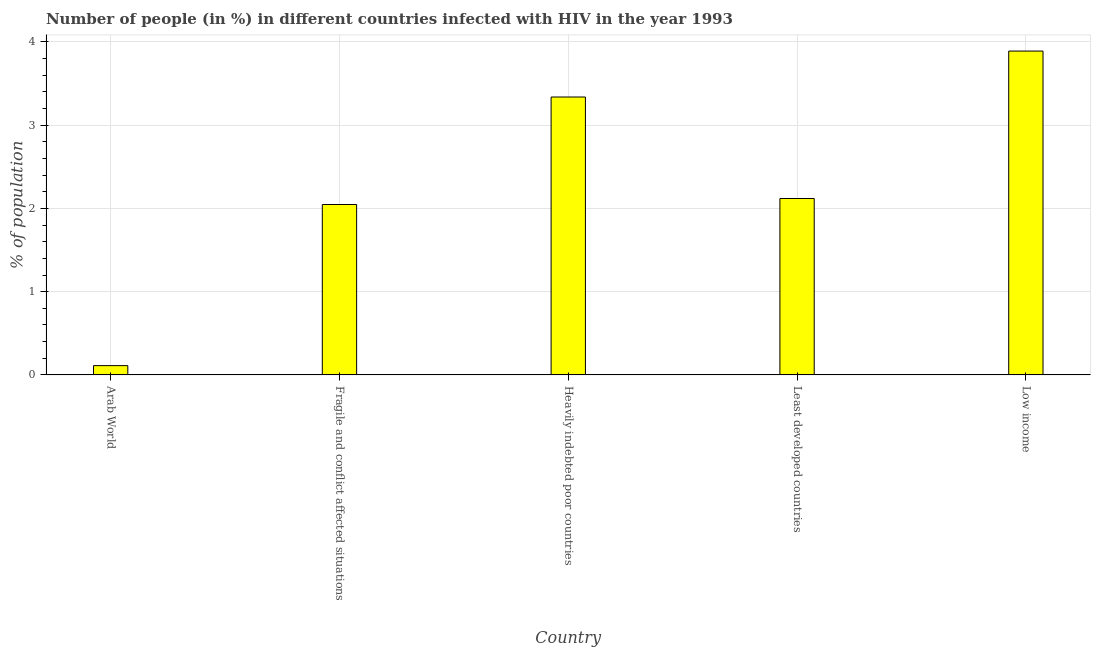Does the graph contain any zero values?
Provide a short and direct response. No. What is the title of the graph?
Provide a short and direct response. Number of people (in %) in different countries infected with HIV in the year 1993. What is the label or title of the Y-axis?
Give a very brief answer. % of population. What is the number of people infected with hiv in Arab World?
Provide a short and direct response. 0.11. Across all countries, what is the maximum number of people infected with hiv?
Your answer should be compact. 3.89. Across all countries, what is the minimum number of people infected with hiv?
Give a very brief answer. 0.11. In which country was the number of people infected with hiv maximum?
Offer a terse response. Low income. In which country was the number of people infected with hiv minimum?
Give a very brief answer. Arab World. What is the sum of the number of people infected with hiv?
Provide a short and direct response. 11.51. What is the difference between the number of people infected with hiv in Heavily indebted poor countries and Low income?
Give a very brief answer. -0.55. What is the average number of people infected with hiv per country?
Provide a short and direct response. 2.3. What is the median number of people infected with hiv?
Your answer should be compact. 2.12. What is the ratio of the number of people infected with hiv in Fragile and conflict affected situations to that in Heavily indebted poor countries?
Provide a short and direct response. 0.61. Is the number of people infected with hiv in Heavily indebted poor countries less than that in Least developed countries?
Your answer should be compact. No. Is the difference between the number of people infected with hiv in Arab World and Least developed countries greater than the difference between any two countries?
Offer a terse response. No. What is the difference between the highest and the second highest number of people infected with hiv?
Provide a succinct answer. 0.55. Is the sum of the number of people infected with hiv in Arab World and Low income greater than the maximum number of people infected with hiv across all countries?
Keep it short and to the point. Yes. What is the difference between the highest and the lowest number of people infected with hiv?
Provide a succinct answer. 3.78. In how many countries, is the number of people infected with hiv greater than the average number of people infected with hiv taken over all countries?
Provide a succinct answer. 2. What is the % of population of Arab World?
Your answer should be very brief. 0.11. What is the % of population in Fragile and conflict affected situations?
Your answer should be compact. 2.05. What is the % of population of Heavily indebted poor countries?
Offer a very short reply. 3.34. What is the % of population in Least developed countries?
Keep it short and to the point. 2.12. What is the % of population of Low income?
Make the answer very short. 3.89. What is the difference between the % of population in Arab World and Fragile and conflict affected situations?
Your answer should be very brief. -1.94. What is the difference between the % of population in Arab World and Heavily indebted poor countries?
Provide a succinct answer. -3.23. What is the difference between the % of population in Arab World and Least developed countries?
Your answer should be very brief. -2.01. What is the difference between the % of population in Arab World and Low income?
Provide a succinct answer. -3.78. What is the difference between the % of population in Fragile and conflict affected situations and Heavily indebted poor countries?
Your response must be concise. -1.29. What is the difference between the % of population in Fragile and conflict affected situations and Least developed countries?
Provide a short and direct response. -0.07. What is the difference between the % of population in Fragile and conflict affected situations and Low income?
Your answer should be very brief. -1.84. What is the difference between the % of population in Heavily indebted poor countries and Least developed countries?
Keep it short and to the point. 1.22. What is the difference between the % of population in Heavily indebted poor countries and Low income?
Offer a very short reply. -0.55. What is the difference between the % of population in Least developed countries and Low income?
Make the answer very short. -1.77. What is the ratio of the % of population in Arab World to that in Fragile and conflict affected situations?
Offer a terse response. 0.05. What is the ratio of the % of population in Arab World to that in Heavily indebted poor countries?
Ensure brevity in your answer.  0.03. What is the ratio of the % of population in Arab World to that in Least developed countries?
Offer a very short reply. 0.05. What is the ratio of the % of population in Arab World to that in Low income?
Provide a succinct answer. 0.03. What is the ratio of the % of population in Fragile and conflict affected situations to that in Heavily indebted poor countries?
Ensure brevity in your answer.  0.61. What is the ratio of the % of population in Fragile and conflict affected situations to that in Least developed countries?
Your answer should be very brief. 0.97. What is the ratio of the % of population in Fragile and conflict affected situations to that in Low income?
Offer a terse response. 0.53. What is the ratio of the % of population in Heavily indebted poor countries to that in Least developed countries?
Ensure brevity in your answer.  1.57. What is the ratio of the % of population in Heavily indebted poor countries to that in Low income?
Make the answer very short. 0.86. What is the ratio of the % of population in Least developed countries to that in Low income?
Your answer should be compact. 0.55. 